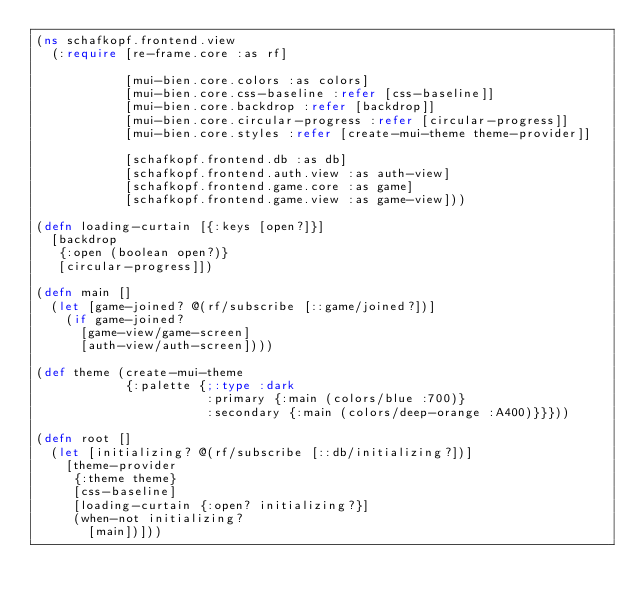<code> <loc_0><loc_0><loc_500><loc_500><_Clojure_>(ns schafkopf.frontend.view
  (:require [re-frame.core :as rf]
            
            [mui-bien.core.colors :as colors]
            [mui-bien.core.css-baseline :refer [css-baseline]]
            [mui-bien.core.backdrop :refer [backdrop]]
            [mui-bien.core.circular-progress :refer [circular-progress]]
            [mui-bien.core.styles :refer [create-mui-theme theme-provider]]

            [schafkopf.frontend.db :as db]
            [schafkopf.frontend.auth.view :as auth-view]
            [schafkopf.frontend.game.core :as game]
            [schafkopf.frontend.game.view :as game-view]))

(defn loading-curtain [{:keys [open?]}]
  [backdrop
   {:open (boolean open?)}
   [circular-progress]])

(defn main []
  (let [game-joined? @(rf/subscribe [::game/joined?])]
    (if game-joined?
      [game-view/game-screen]
      [auth-view/auth-screen])))

(def theme (create-mui-theme
            {:palette {;:type :dark
                       :primary {:main (colors/blue :700)}
                       :secondary {:main (colors/deep-orange :A400)}}}))

(defn root []
  (let [initializing? @(rf/subscribe [::db/initializing?])]
    [theme-provider
     {:theme theme}
     [css-baseline]
     [loading-curtain {:open? initializing?}]
     (when-not initializing?
       [main])]))
</code> 